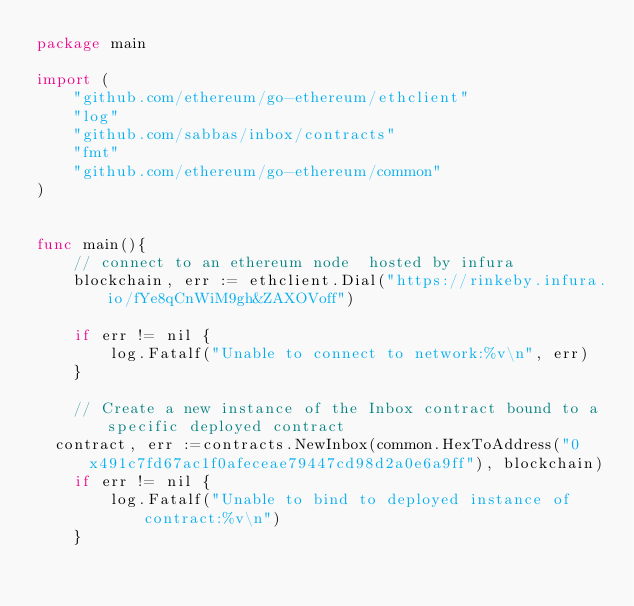Convert code to text. <code><loc_0><loc_0><loc_500><loc_500><_Go_>package main

import (
	"github.com/ethereum/go-ethereum/ethclient"
	"log"
	"github.com/sabbas/inbox/contracts"
	"fmt"
	"github.com/ethereum/go-ethereum/common"
)


func main(){
	// connect to an ethereum node  hosted by infura
	blockchain, err := ethclient.Dial("https://rinkeby.infura.io/fYe8qCnWiM9gh&ZAXOVoff")

	if err != nil {
		log.Fatalf("Unable to connect to network:%v\n", err)
	}

	// Create a new instance of the Inbox contract bound to a specific deployed contract
  contract, err :=contracts.NewInbox(common.HexToAddress("0x491c7fd67ac1f0afeceae79447cd98d2a0e6a9ff"), blockchain)
	if err != nil {
		log.Fatalf("Unable to bind to deployed instance of contract:%v\n")
	}
</code> 